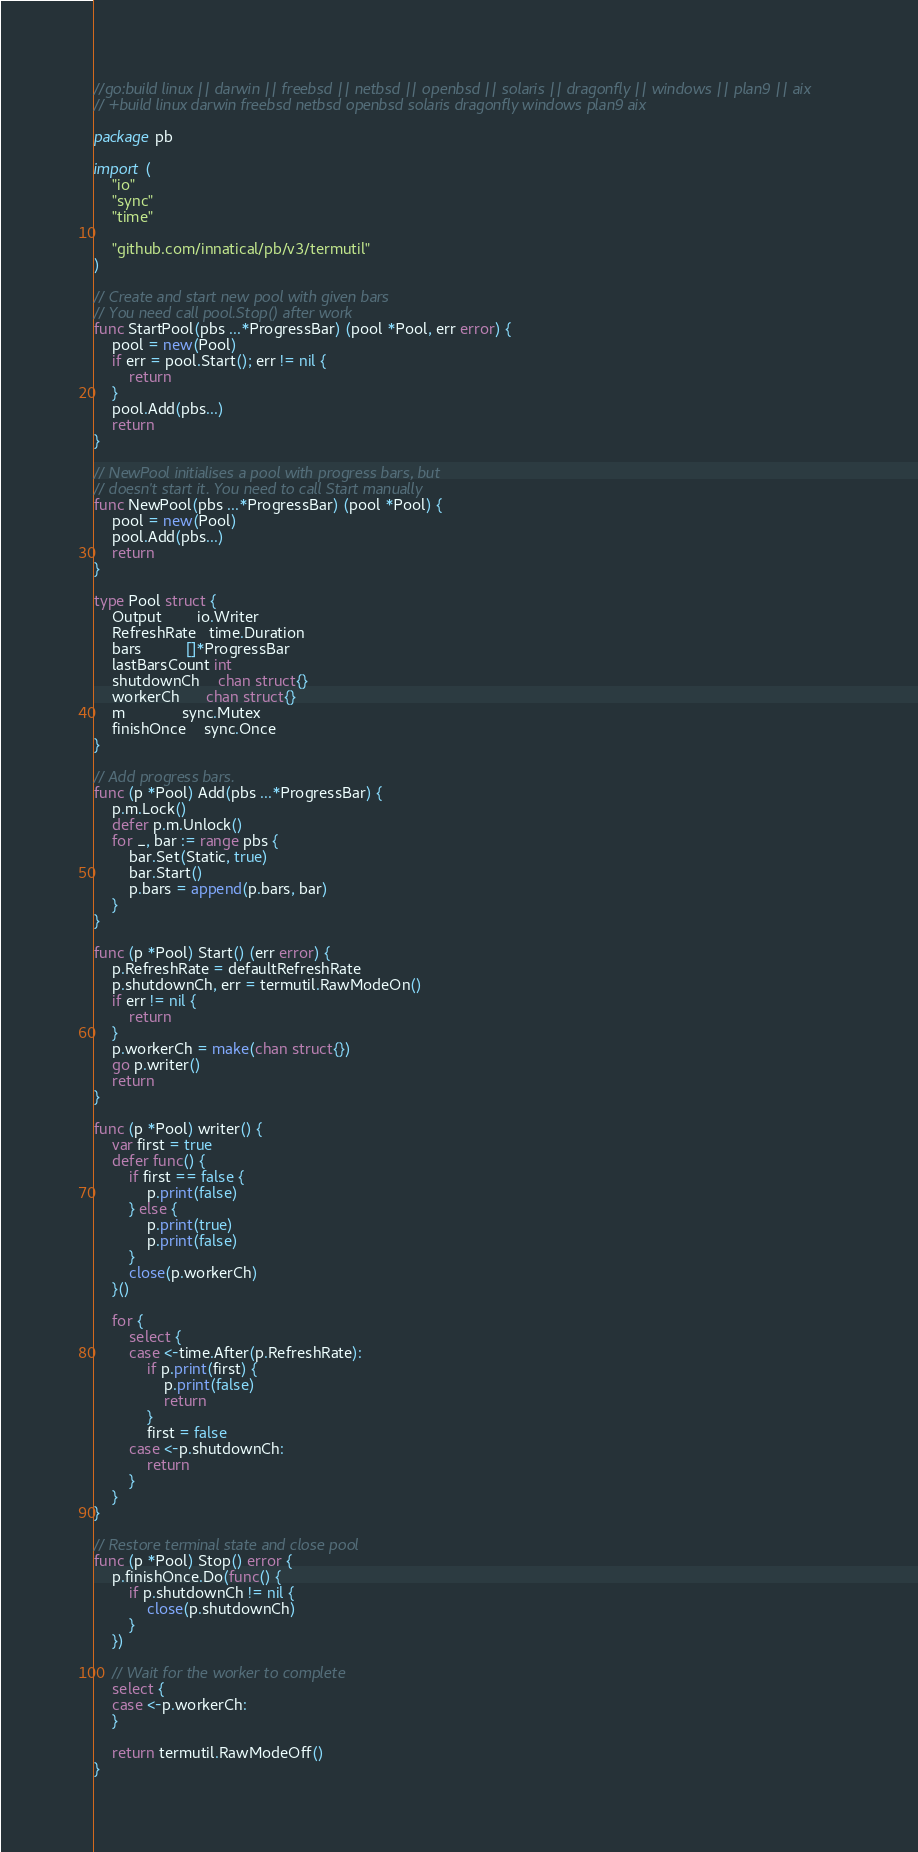<code> <loc_0><loc_0><loc_500><loc_500><_Go_>//go:build linux || darwin || freebsd || netbsd || openbsd || solaris || dragonfly || windows || plan9 || aix
// +build linux darwin freebsd netbsd openbsd solaris dragonfly windows plan9 aix

package pb

import (
	"io"
	"sync"
	"time"

	"github.com/innatical/pb/v3/termutil"
)

// Create and start new pool with given bars
// You need call pool.Stop() after work
func StartPool(pbs ...*ProgressBar) (pool *Pool, err error) {
	pool = new(Pool)
	if err = pool.Start(); err != nil {
		return
	}
	pool.Add(pbs...)
	return
}

// NewPool initialises a pool with progress bars, but
// doesn't start it. You need to call Start manually
func NewPool(pbs ...*ProgressBar) (pool *Pool) {
	pool = new(Pool)
	pool.Add(pbs...)
	return
}

type Pool struct {
	Output        io.Writer
	RefreshRate   time.Duration
	bars          []*ProgressBar
	lastBarsCount int
	shutdownCh    chan struct{}
	workerCh      chan struct{}
	m             sync.Mutex
	finishOnce    sync.Once
}

// Add progress bars.
func (p *Pool) Add(pbs ...*ProgressBar) {
	p.m.Lock()
	defer p.m.Unlock()
	for _, bar := range pbs {
		bar.Set(Static, true)
		bar.Start()
		p.bars = append(p.bars, bar)
	}
}

func (p *Pool) Start() (err error) {
	p.RefreshRate = defaultRefreshRate
	p.shutdownCh, err = termutil.RawModeOn()
	if err != nil {
		return
	}
	p.workerCh = make(chan struct{})
	go p.writer()
	return
}

func (p *Pool) writer() {
	var first = true
	defer func() {
		if first == false {
			p.print(false)
		} else {
			p.print(true)
			p.print(false)
		}
		close(p.workerCh)
	}()

	for {
		select {
		case <-time.After(p.RefreshRate):
			if p.print(first) {
				p.print(false)
				return
			}
			first = false
		case <-p.shutdownCh:
			return
		}
	}
}

// Restore terminal state and close pool
func (p *Pool) Stop() error {
	p.finishOnce.Do(func() {
		if p.shutdownCh != nil {
			close(p.shutdownCh)
		}
	})

	// Wait for the worker to complete
	select {
	case <-p.workerCh:
	}

	return termutil.RawModeOff()
}
</code> 